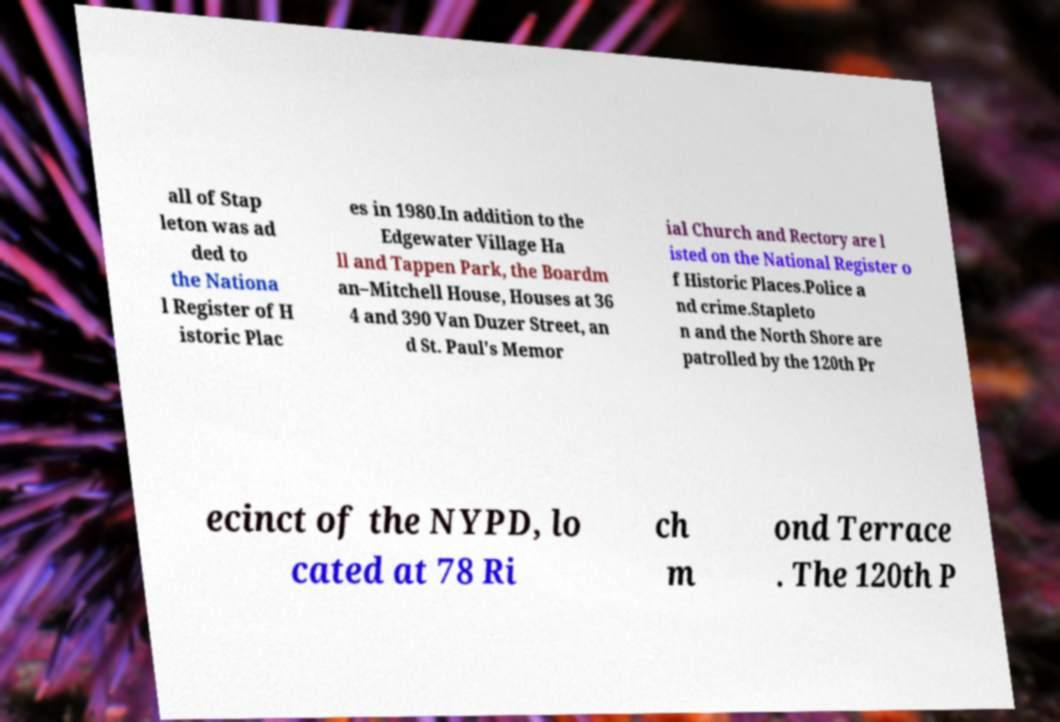Please identify and transcribe the text found in this image. all of Stap leton was ad ded to the Nationa l Register of H istoric Plac es in 1980.In addition to the Edgewater Village Ha ll and Tappen Park, the Boardm an–Mitchell House, Houses at 36 4 and 390 Van Duzer Street, an d St. Paul's Memor ial Church and Rectory are l isted on the National Register o f Historic Places.Police a nd crime.Stapleto n and the North Shore are patrolled by the 120th Pr ecinct of the NYPD, lo cated at 78 Ri ch m ond Terrace . The 120th P 